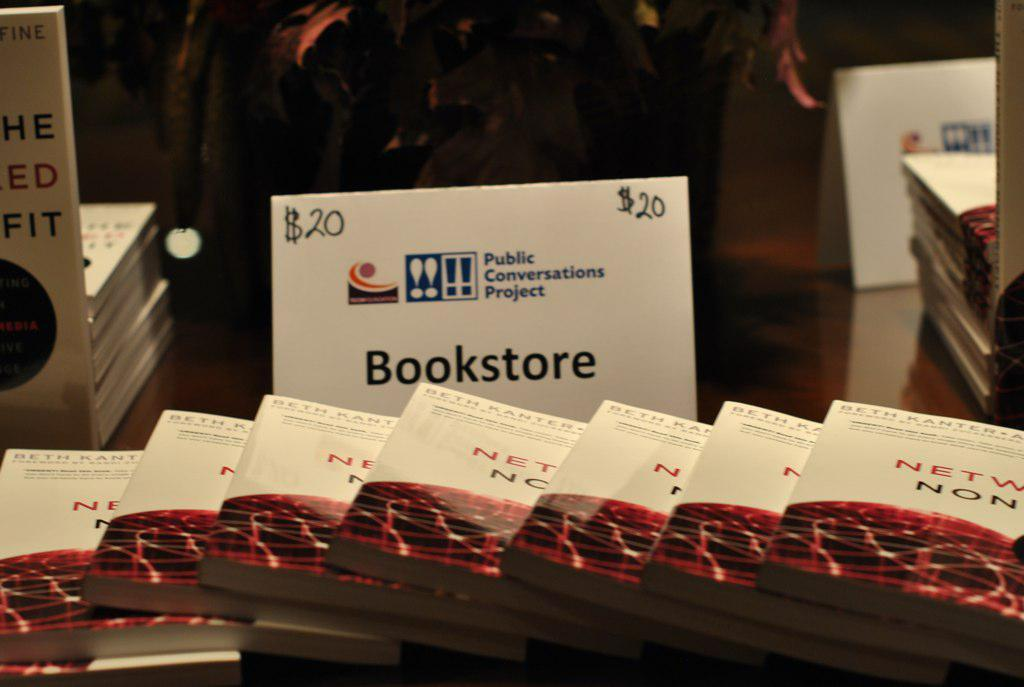What type of furniture is present in the image? There is a table in the image. What items are placed on the table? There are books and boards on the table. Where is the cactus located in the image? There is no cactus present in the image. What type of metal is used to make the boards in the image? There is no information about the material of the boards in the image. 